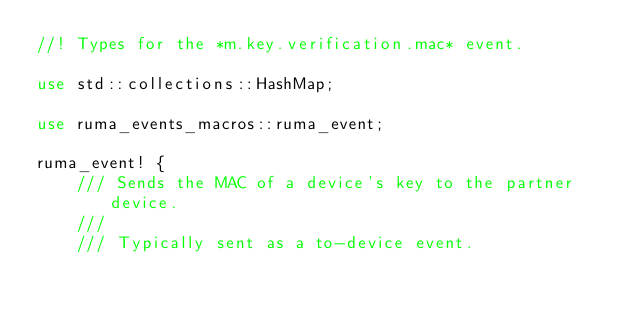<code> <loc_0><loc_0><loc_500><loc_500><_Rust_>//! Types for the *m.key.verification.mac* event.

use std::collections::HashMap;

use ruma_events_macros::ruma_event;

ruma_event! {
    /// Sends the MAC of a device's key to the partner device.
    ///
    /// Typically sent as a to-device event.</code> 